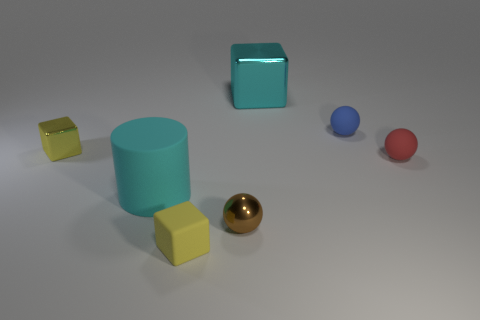Is the number of shiny things that are in front of the matte cylinder greater than the number of small yellow shiny objects that are in front of the tiny brown shiny ball?
Make the answer very short. Yes. Do the large object that is in front of the big cyan block and the shiny object behind the blue matte object have the same color?
Offer a very short reply. Yes. What size is the brown metallic thing that is in front of the tiny yellow cube to the left of the big cyan thing in front of the tiny yellow metallic block?
Keep it short and to the point. Small. What is the color of the small metal thing that is the same shape as the yellow rubber thing?
Ensure brevity in your answer.  Yellow. Is the number of blue things that are in front of the large cyan metallic cube greater than the number of large purple shiny balls?
Your response must be concise. Yes. Does the tiny blue object have the same shape as the metallic object that is in front of the small yellow metal cube?
Your answer should be compact. Yes. What size is the blue rubber object that is the same shape as the brown object?
Make the answer very short. Small. Is the number of small blue metal cylinders greater than the number of tiny yellow matte things?
Give a very brief answer. No. Does the blue thing have the same shape as the yellow metallic object?
Your answer should be compact. No. What material is the yellow cube that is in front of the sphere on the left side of the tiny blue ball?
Your response must be concise. Rubber. 